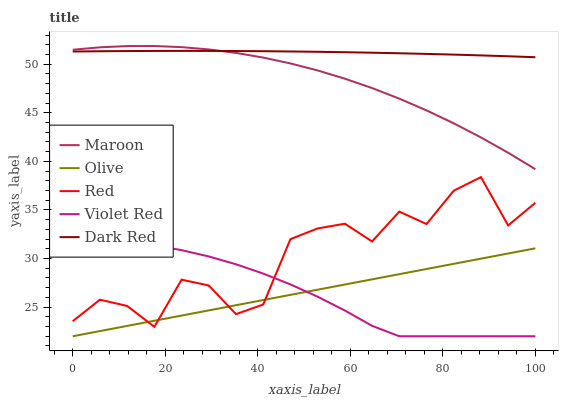Does Olive have the minimum area under the curve?
Answer yes or no. Yes. Does Dark Red have the maximum area under the curve?
Answer yes or no. Yes. Does Violet Red have the minimum area under the curve?
Answer yes or no. No. Does Violet Red have the maximum area under the curve?
Answer yes or no. No. Is Olive the smoothest?
Answer yes or no. Yes. Is Red the roughest?
Answer yes or no. Yes. Is Dark Red the smoothest?
Answer yes or no. No. Is Dark Red the roughest?
Answer yes or no. No. Does Olive have the lowest value?
Answer yes or no. Yes. Does Dark Red have the lowest value?
Answer yes or no. No. Does Maroon have the highest value?
Answer yes or no. Yes. Does Dark Red have the highest value?
Answer yes or no. No. Is Olive less than Maroon?
Answer yes or no. Yes. Is Maroon greater than Violet Red?
Answer yes or no. Yes. Does Olive intersect Violet Red?
Answer yes or no. Yes. Is Olive less than Violet Red?
Answer yes or no. No. Is Olive greater than Violet Red?
Answer yes or no. No. Does Olive intersect Maroon?
Answer yes or no. No. 